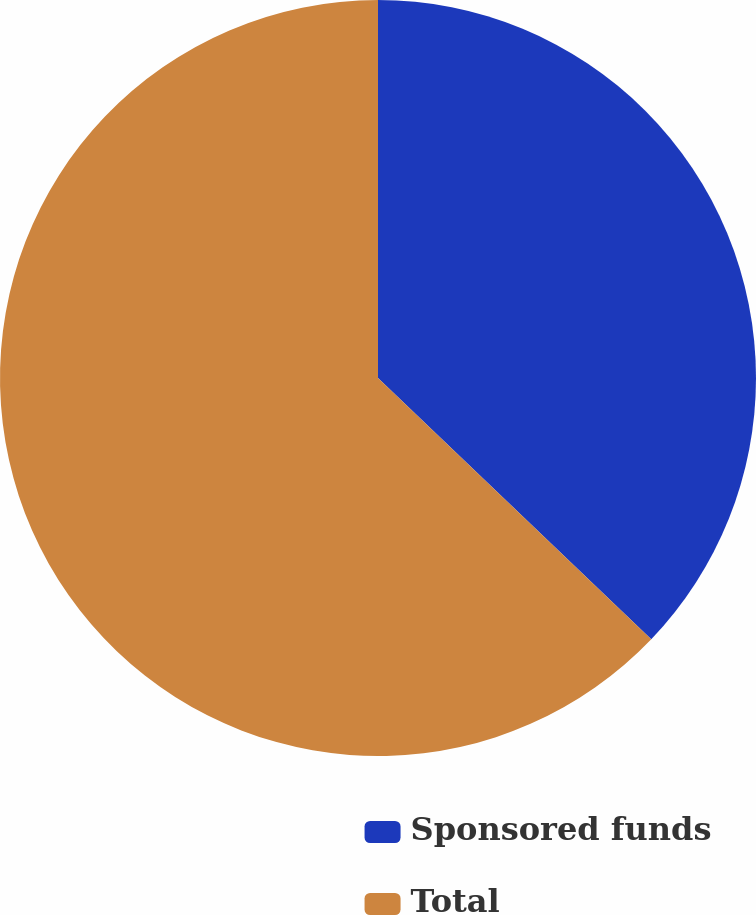Convert chart. <chart><loc_0><loc_0><loc_500><loc_500><pie_chart><fcel>Sponsored funds<fcel>Total<nl><fcel>37.14%<fcel>62.86%<nl></chart> 